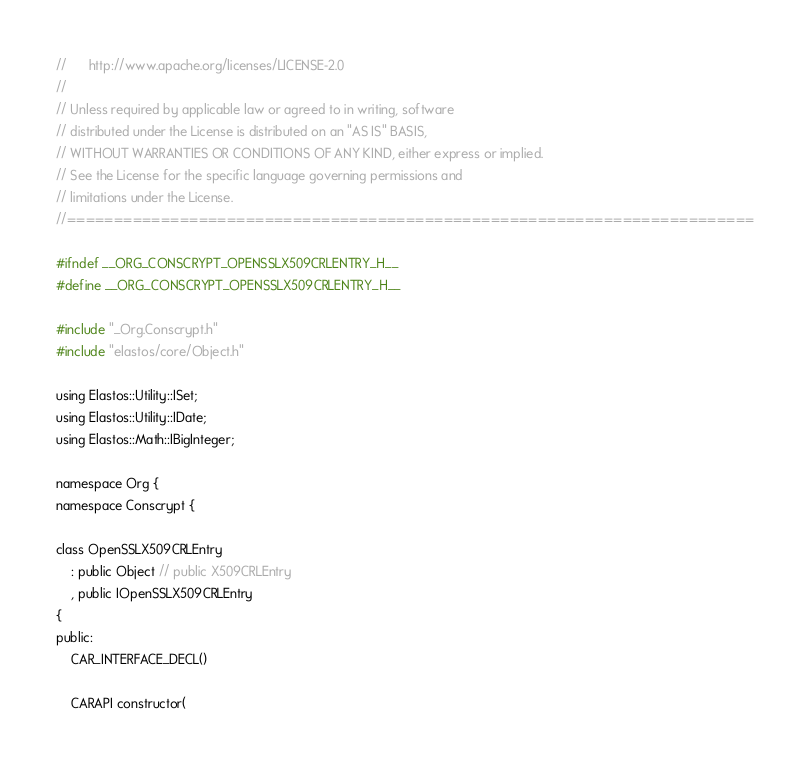Convert code to text. <code><loc_0><loc_0><loc_500><loc_500><_C_>//      http://www.apache.org/licenses/LICENSE-2.0
//
// Unless required by applicable law or agreed to in writing, software
// distributed under the License is distributed on an "AS IS" BASIS,
// WITHOUT WARRANTIES OR CONDITIONS OF ANY KIND, either express or implied.
// See the License for the specific language governing permissions and
// limitations under the License.
//=========================================================================

#ifndef __ORG_CONSCRYPT_OPENSSLX509CRLENTRY_H__
#define __ORG_CONSCRYPT_OPENSSLX509CRLENTRY_H__

#include "_Org.Conscrypt.h"
#include "elastos/core/Object.h"

using Elastos::Utility::ISet;
using Elastos::Utility::IDate;
using Elastos::Math::IBigInteger;

namespace Org {
namespace Conscrypt {

class OpenSSLX509CRLEntry
    : public Object // public X509CRLEntry
    , public IOpenSSLX509CRLEntry
{
public:
    CAR_INTERFACE_DECL()

    CARAPI constructor(</code> 